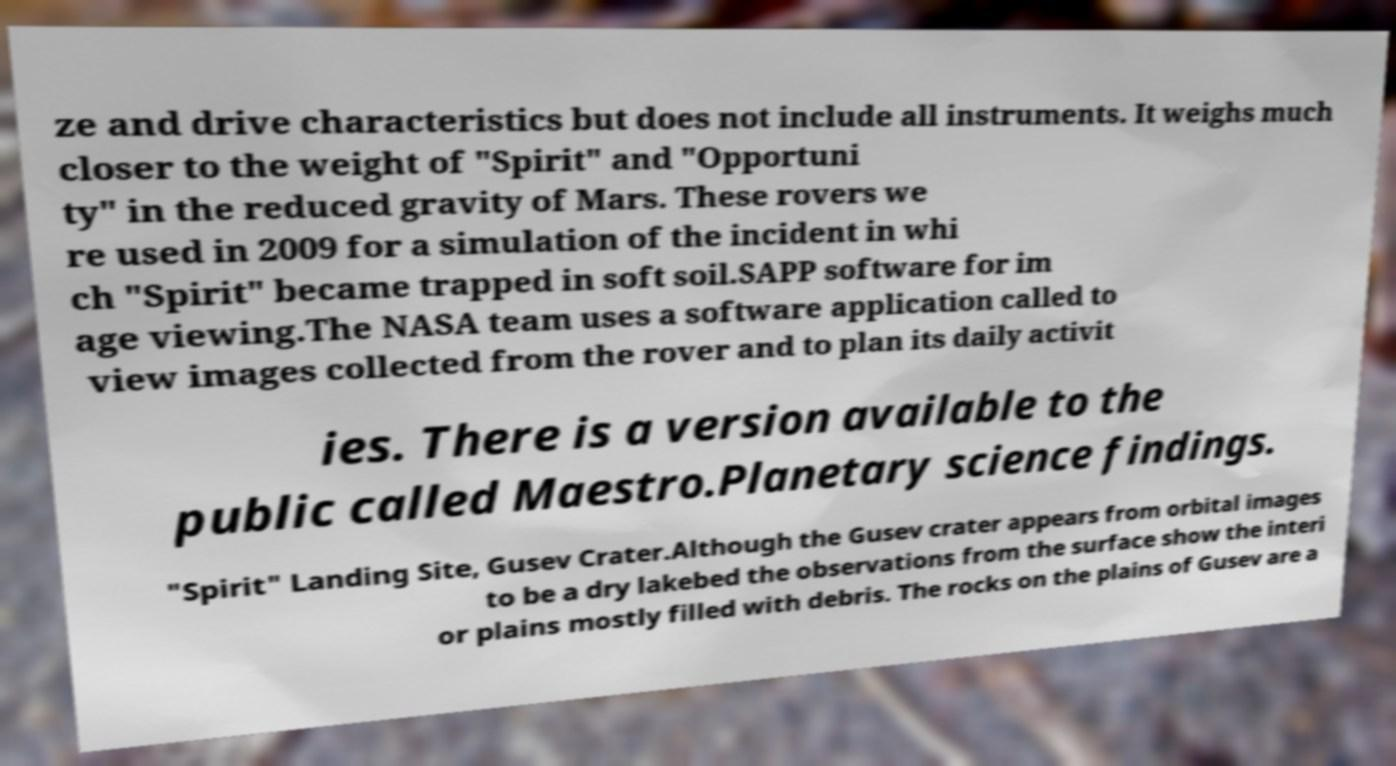Please read and relay the text visible in this image. What does it say? ze and drive characteristics but does not include all instruments. It weighs much closer to the weight of "Spirit" and "Opportuni ty" in the reduced gravity of Mars. These rovers we re used in 2009 for a simulation of the incident in whi ch "Spirit" became trapped in soft soil.SAPP software for im age viewing.The NASA team uses a software application called to view images collected from the rover and to plan its daily activit ies. There is a version available to the public called Maestro.Planetary science findings. "Spirit" Landing Site, Gusev Crater.Although the Gusev crater appears from orbital images to be a dry lakebed the observations from the surface show the interi or plains mostly filled with debris. The rocks on the plains of Gusev are a 